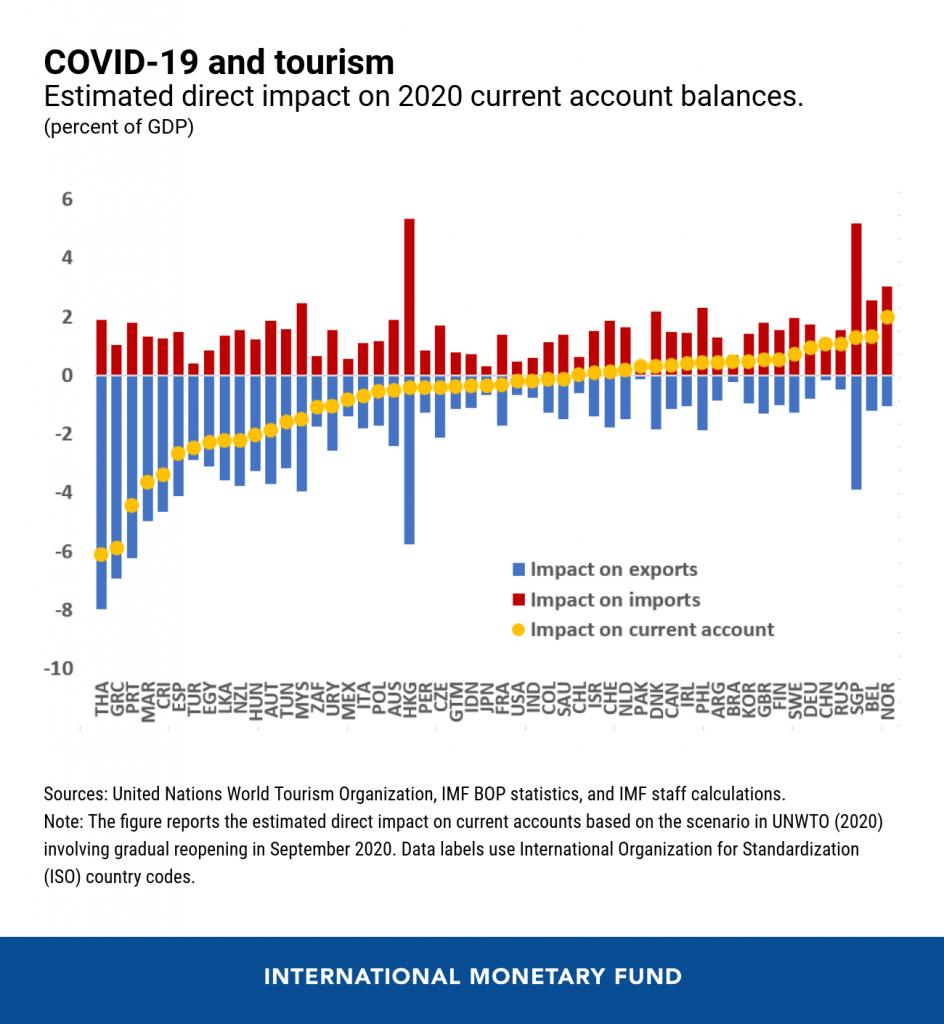Indicate a few pertinent items in this graphic. The country that has the highest positive impact on current account is Norway. The color blue is commonly used to represent the impact of exports on a country's economy. In Hong Kong and Singapore, the impact of the COVID-19 pandemic on imports has been the highest. 